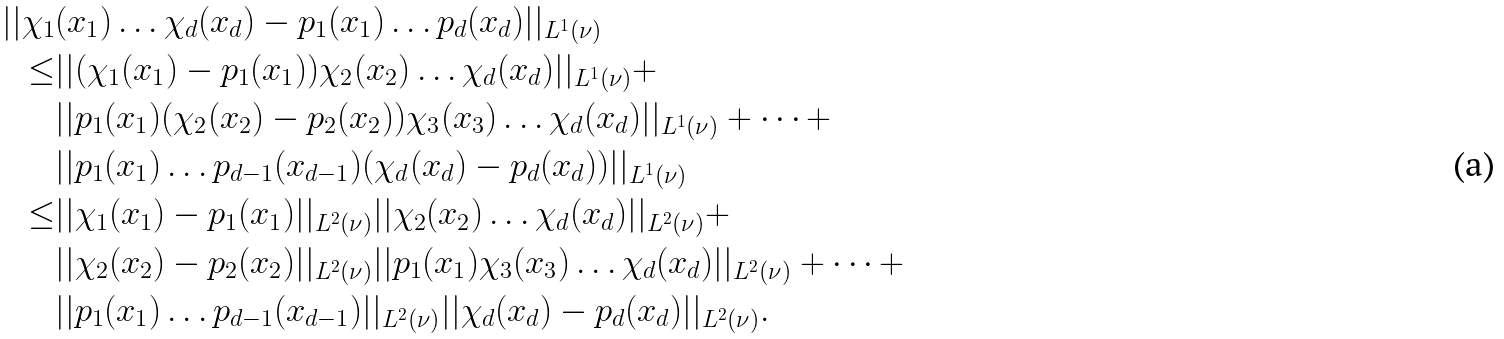Convert formula to latex. <formula><loc_0><loc_0><loc_500><loc_500>| | \chi _ { 1 } & ( x _ { 1 } ) \dots \chi _ { d } ( x _ { d } ) - p _ { 1 } ( x _ { 1 } ) \dots p _ { d } ( x _ { d } ) | | _ { L ^ { 1 } ( \nu ) } \\ \leq & | | ( \chi _ { 1 } ( x _ { 1 } ) - p _ { 1 } ( x _ { 1 } ) ) \chi _ { 2 } ( x _ { 2 } ) \dots \chi _ { d } ( x _ { d } ) | | _ { L ^ { 1 } ( \nu ) } + \\ & | | p _ { 1 } ( x _ { 1 } ) ( \chi _ { 2 } ( x _ { 2 } ) - p _ { 2 } ( x _ { 2 } ) ) \chi _ { 3 } ( x _ { 3 } ) \dots \chi _ { d } ( x _ { d } ) | | _ { L ^ { 1 } ( \nu ) } + \dots + \\ & | | p _ { 1 } ( x _ { 1 } ) \dots p _ { d - 1 } ( x _ { d - 1 } ) ( \chi _ { d } ( x _ { d } ) - p _ { d } ( x _ { d } ) ) | | _ { L ^ { 1 } ( \nu ) } \\ \leq & | | \chi _ { 1 } ( x _ { 1 } ) - p _ { 1 } ( x _ { 1 } ) | | _ { L ^ { 2 } ( \nu ) } | | \chi _ { 2 } ( x _ { 2 } ) \dots \chi _ { d } ( x _ { d } ) | | _ { L ^ { 2 } ( \nu ) } + \\ & | | \chi _ { 2 } ( x _ { 2 } ) - p _ { 2 } ( x _ { 2 } ) | | _ { L ^ { 2 } ( \nu ) } | | p _ { 1 } ( x _ { 1 } ) \chi _ { 3 } ( x _ { 3 } ) \dots \chi _ { d } ( x _ { d } ) | | _ { L ^ { 2 } ( \nu ) } + \dots + \\ & | | p _ { 1 } ( x _ { 1 } ) \dots p _ { d - 1 } ( x _ { d - 1 } ) | | _ { L ^ { 2 } ( \nu ) } | | \chi _ { d } ( x _ { d } ) - p _ { d } ( x _ { d } ) | | _ { L ^ { 2 } ( \nu ) } .</formula> 